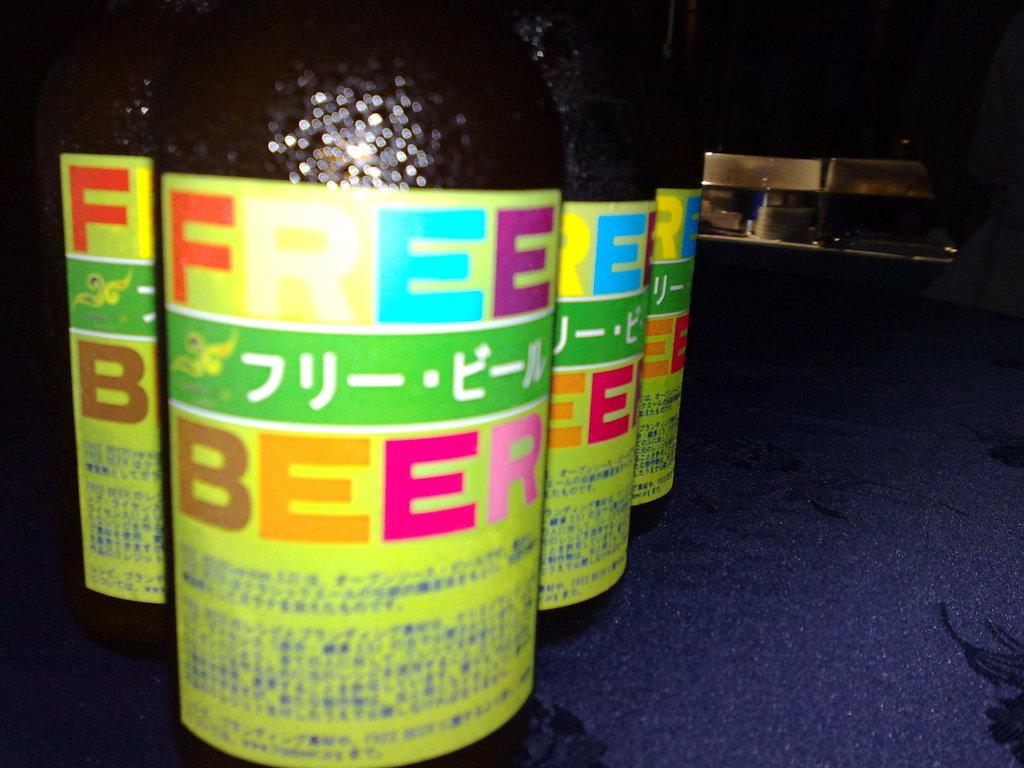What beverage is written on the label?
Provide a succinct answer. Beer. 